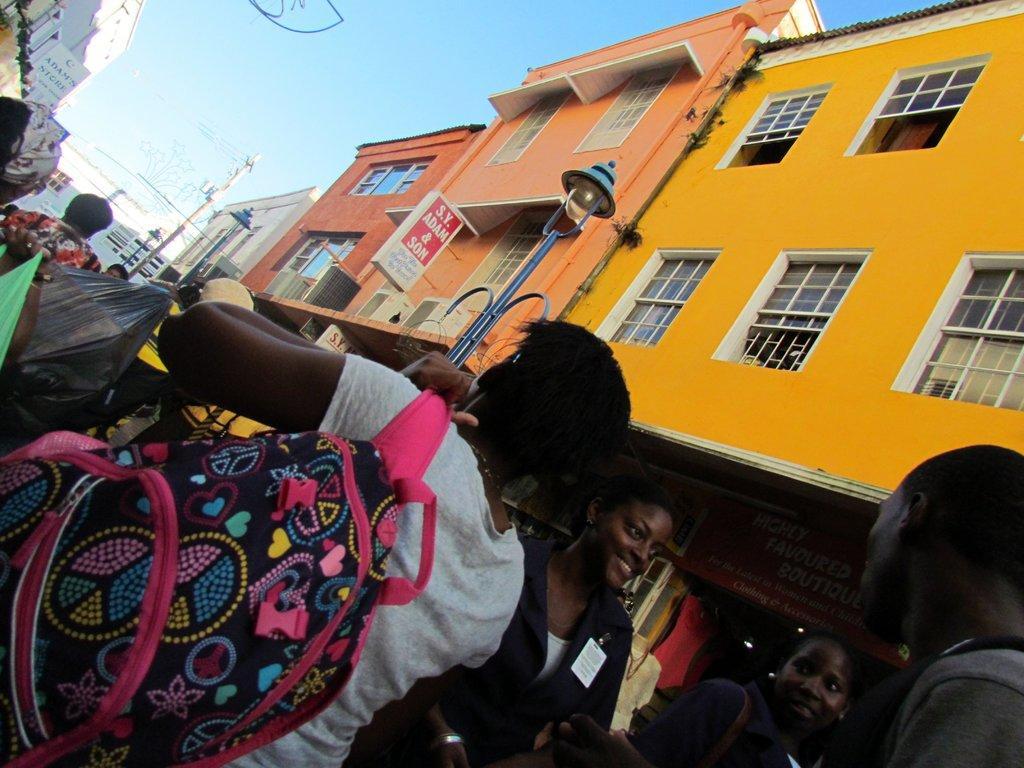Please provide a concise description of this image. This picture describes about group of people, on the left side of the image we can see a person and the person wore a bag, in the background we can see few poles, sign boards lights and buildings. 